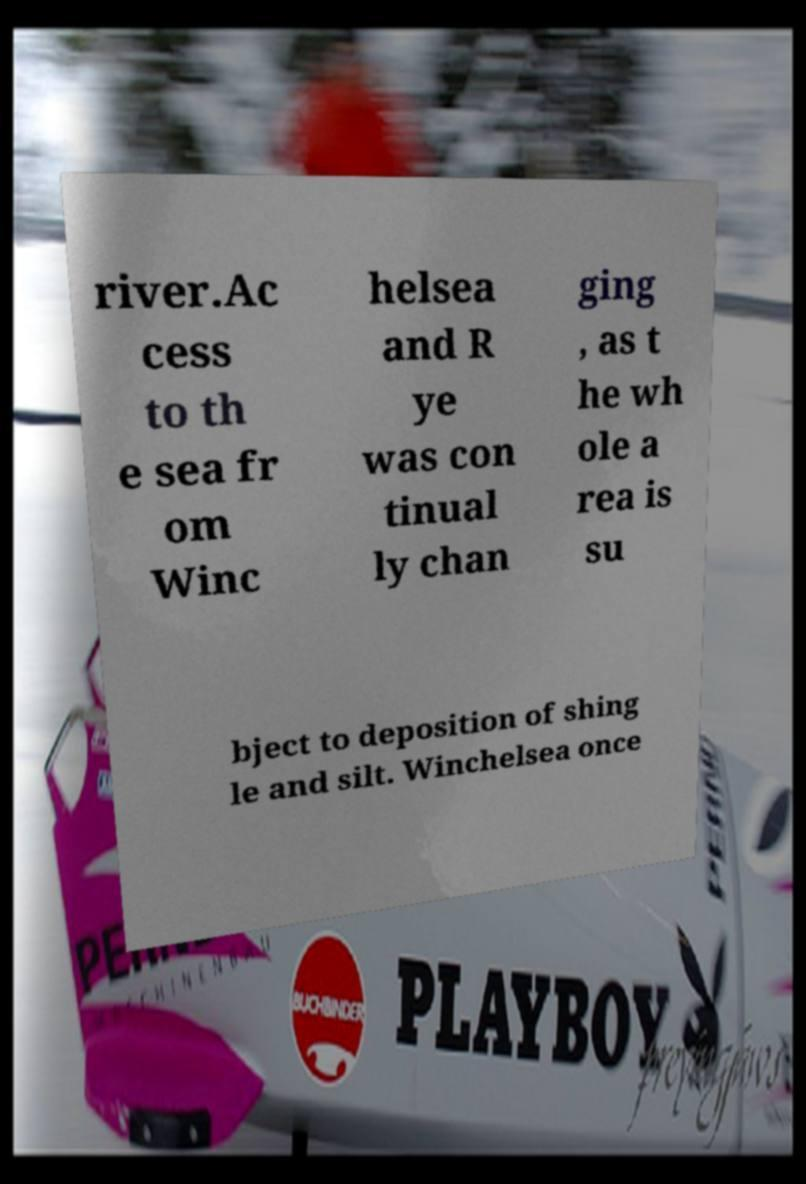Could you extract and type out the text from this image? river.Ac cess to th e sea fr om Winc helsea and R ye was con tinual ly chan ging , as t he wh ole a rea is su bject to deposition of shing le and silt. Winchelsea once 